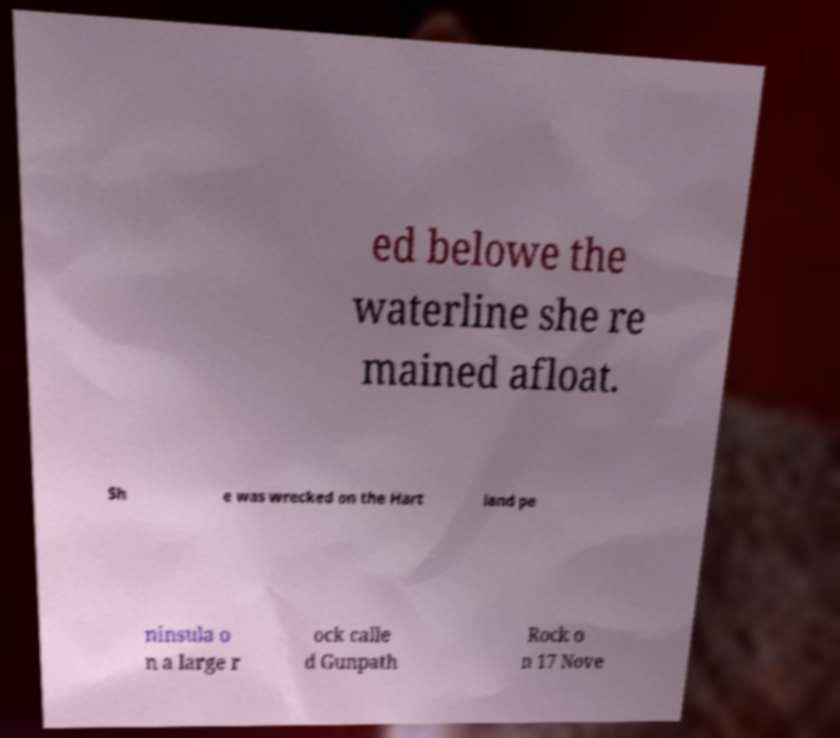What messages or text are displayed in this image? I need them in a readable, typed format. ed belowe the waterline she re mained afloat. Sh e was wrecked on the Hart land pe ninsula o n a large r ock calle d Gunpath Rock o n 17 Nove 